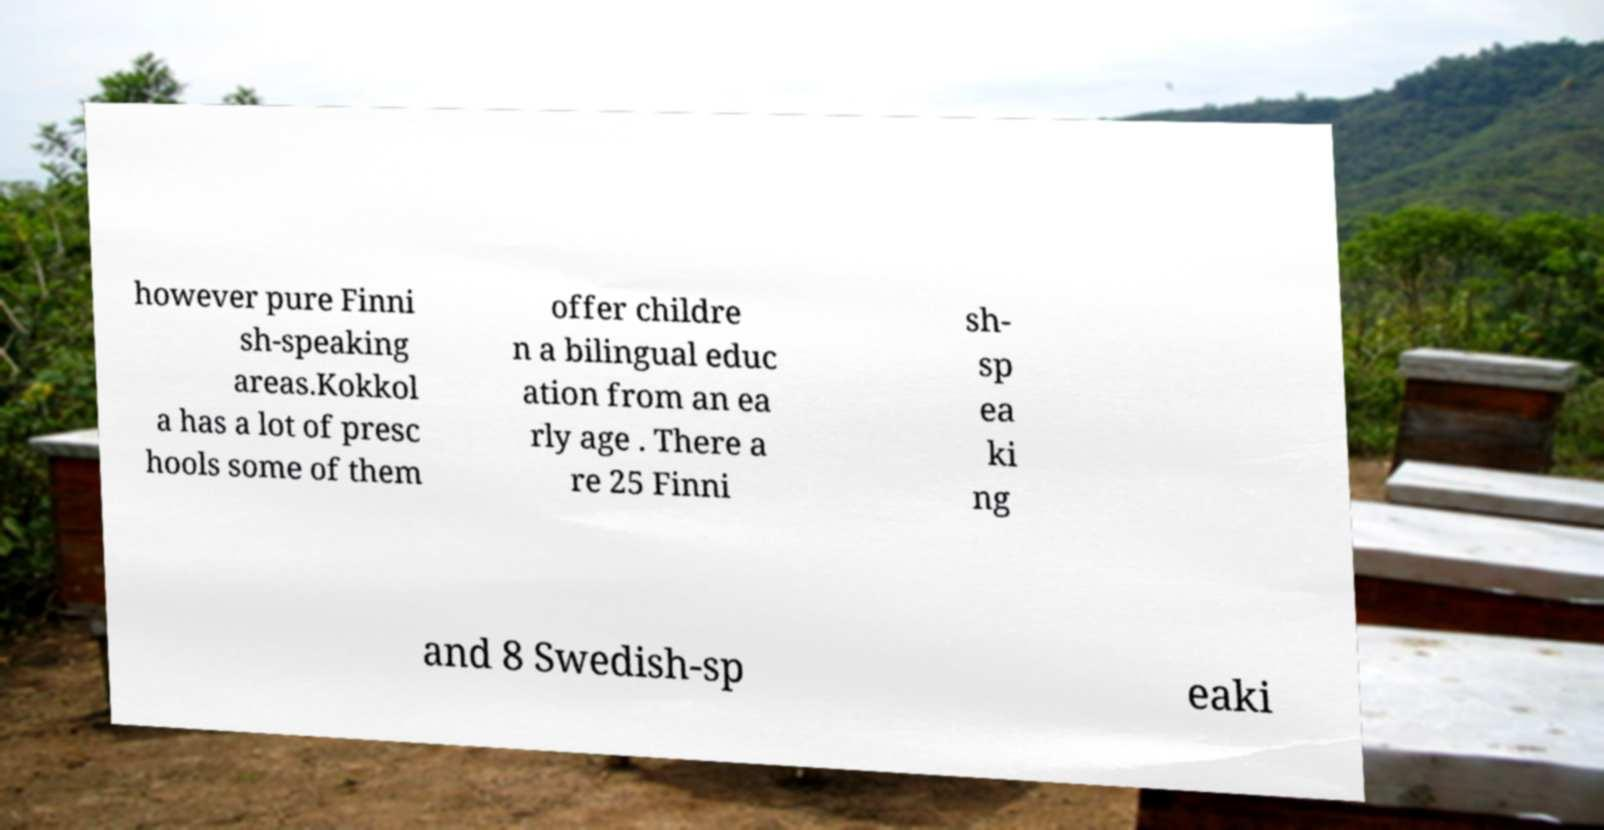Could you assist in decoding the text presented in this image and type it out clearly? however pure Finni sh-speaking areas.Kokkol a has a lot of presc hools some of them offer childre n a bilingual educ ation from an ea rly age . There a re 25 Finni sh- sp ea ki ng and 8 Swedish-sp eaki 